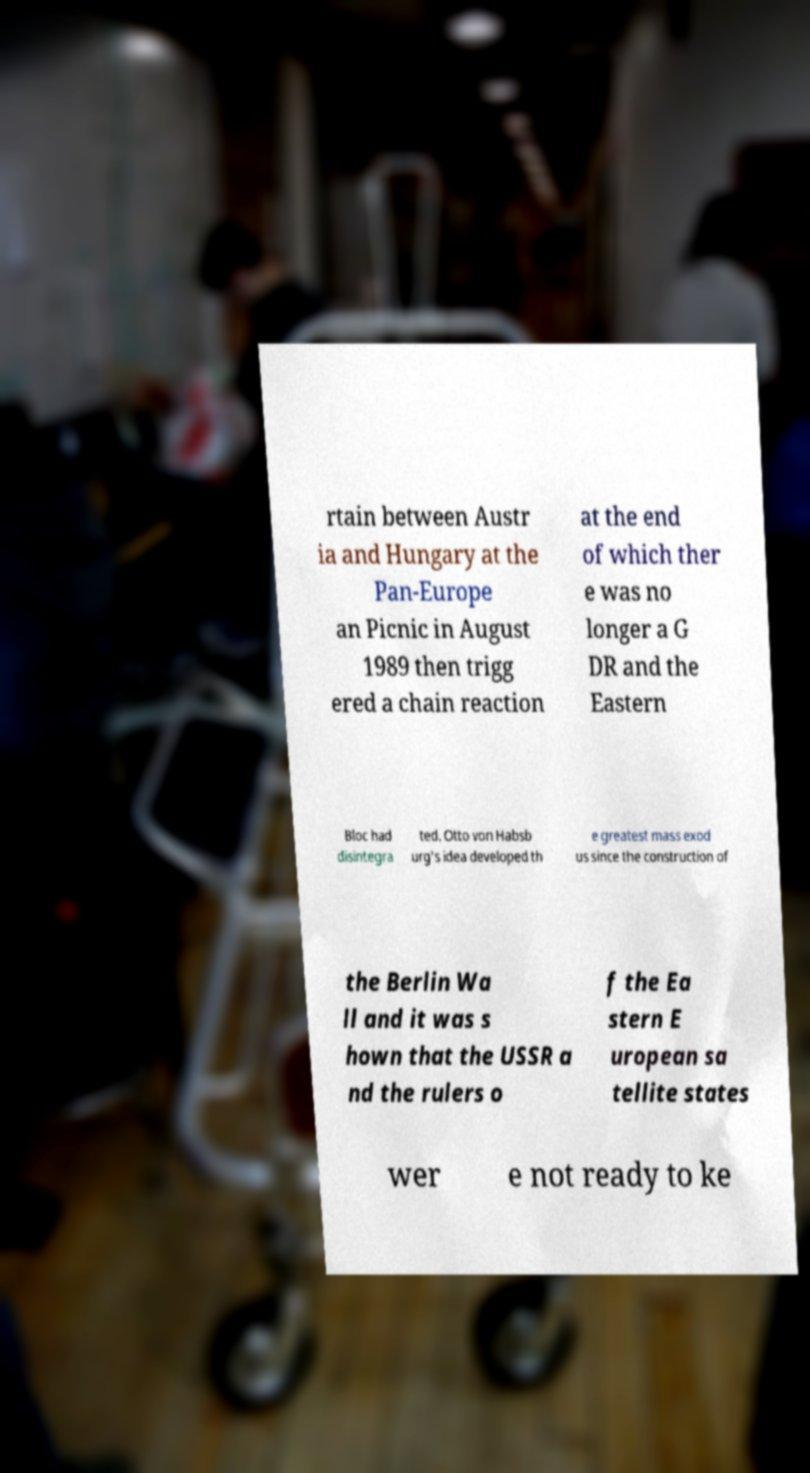Please read and relay the text visible in this image. What does it say? rtain between Austr ia and Hungary at the Pan-Europe an Picnic in August 1989 then trigg ered a chain reaction at the end of which ther e was no longer a G DR and the Eastern Bloc had disintegra ted. Otto von Habsb urg's idea developed th e greatest mass exod us since the construction of the Berlin Wa ll and it was s hown that the USSR a nd the rulers o f the Ea stern E uropean sa tellite states wer e not ready to ke 